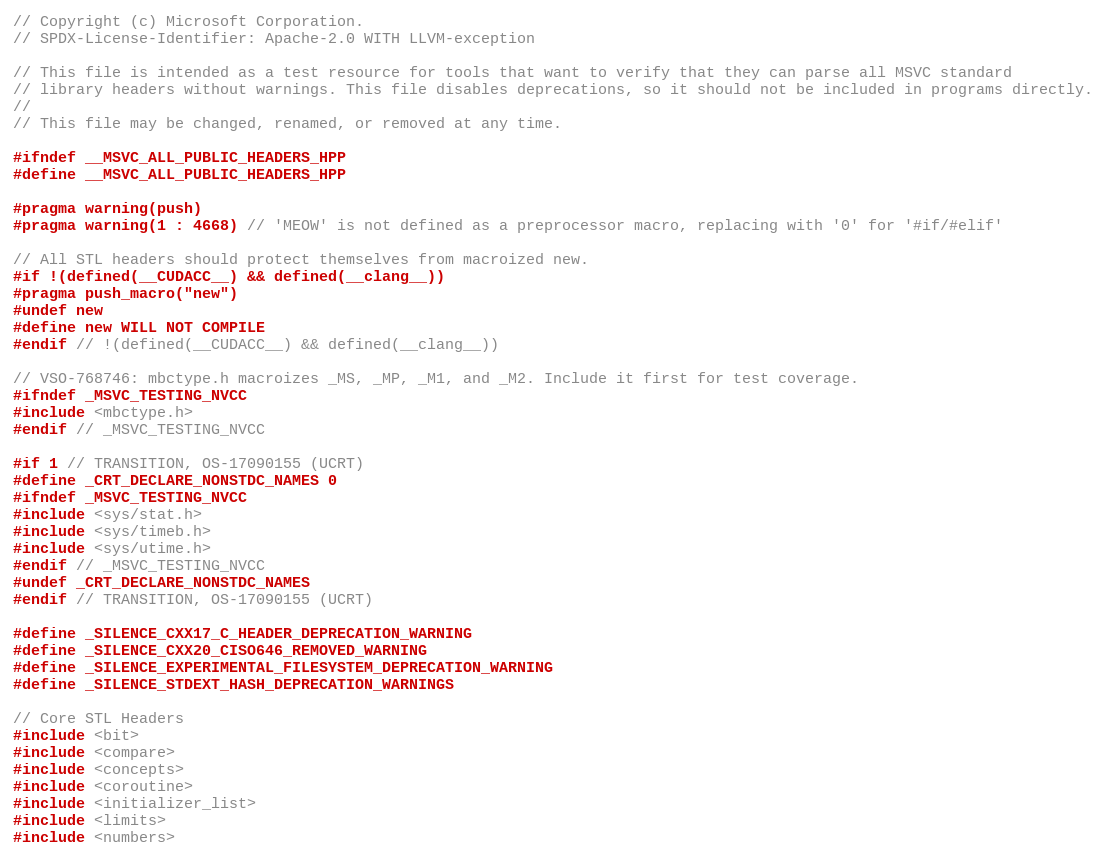Convert code to text. <code><loc_0><loc_0><loc_500><loc_500><_C++_>// Copyright (c) Microsoft Corporation.
// SPDX-License-Identifier: Apache-2.0 WITH LLVM-exception

// This file is intended as a test resource for tools that want to verify that they can parse all MSVC standard
// library headers without warnings. This file disables deprecations, so it should not be included in programs directly.
//
// This file may be changed, renamed, or removed at any time.

#ifndef __MSVC_ALL_PUBLIC_HEADERS_HPP
#define __MSVC_ALL_PUBLIC_HEADERS_HPP

#pragma warning(push)
#pragma warning(1 : 4668) // 'MEOW' is not defined as a preprocessor macro, replacing with '0' for '#if/#elif'

// All STL headers should protect themselves from macroized new.
#if !(defined(__CUDACC__) && defined(__clang__))
#pragma push_macro("new")
#undef new
#define new WILL NOT COMPILE
#endif // !(defined(__CUDACC__) && defined(__clang__))

// VSO-768746: mbctype.h macroizes _MS, _MP, _M1, and _M2. Include it first for test coverage.
#ifndef _MSVC_TESTING_NVCC
#include <mbctype.h>
#endif // _MSVC_TESTING_NVCC

#if 1 // TRANSITION, OS-17090155 (UCRT)
#define _CRT_DECLARE_NONSTDC_NAMES 0
#ifndef _MSVC_TESTING_NVCC
#include <sys/stat.h>
#include <sys/timeb.h>
#include <sys/utime.h>
#endif // _MSVC_TESTING_NVCC
#undef _CRT_DECLARE_NONSTDC_NAMES
#endif // TRANSITION, OS-17090155 (UCRT)

#define _SILENCE_CXX17_C_HEADER_DEPRECATION_WARNING
#define _SILENCE_CXX20_CISO646_REMOVED_WARNING
#define _SILENCE_EXPERIMENTAL_FILESYSTEM_DEPRECATION_WARNING
#define _SILENCE_STDEXT_HASH_DEPRECATION_WARNINGS

// Core STL Headers
#include <bit>
#include <compare>
#include <concepts>
#include <coroutine>
#include <initializer_list>
#include <limits>
#include <numbers></code> 